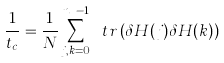<formula> <loc_0><loc_0><loc_500><loc_500>\frac { 1 } { t _ { c } } = \frac { 1 } { N } \sum _ { j , k = 0 } ^ { n _ { g } - 1 } \ t r \left ( \delta H ( j ) \delta H ( k ) \right )</formula> 